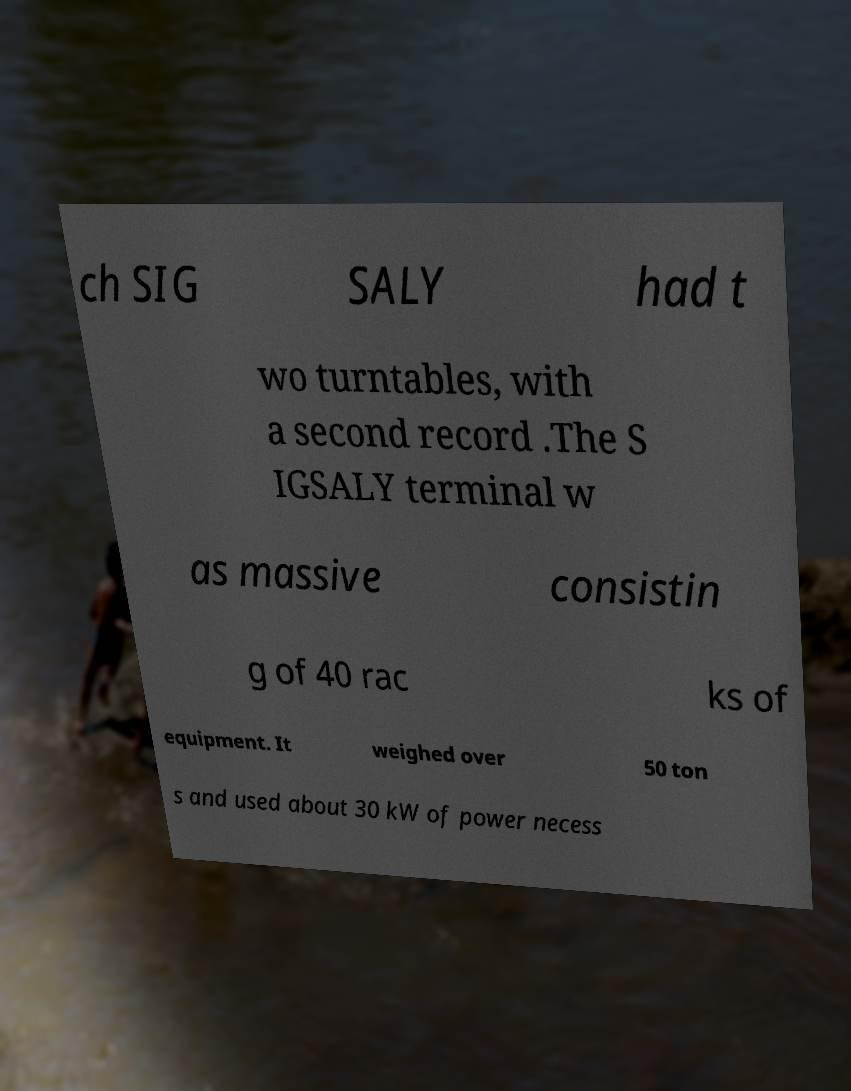For documentation purposes, I need the text within this image transcribed. Could you provide that? ch SIG SALY had t wo turntables, with a second record .The S IGSALY terminal w as massive consistin g of 40 rac ks of equipment. It weighed over 50 ton s and used about 30 kW of power necess 